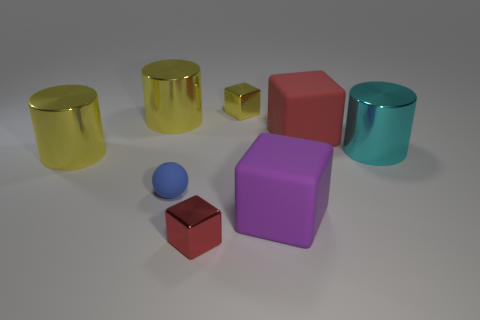Subtract all green balls. Subtract all brown cylinders. How many balls are left? 1 Add 1 tiny blue rubber spheres. How many objects exist? 9 Subtract all spheres. How many objects are left? 7 Subtract 1 purple blocks. How many objects are left? 7 Subtract all cyan shiny things. Subtract all red shiny cubes. How many objects are left? 6 Add 6 blue matte spheres. How many blue matte spheres are left? 7 Add 1 metal cubes. How many metal cubes exist? 3 